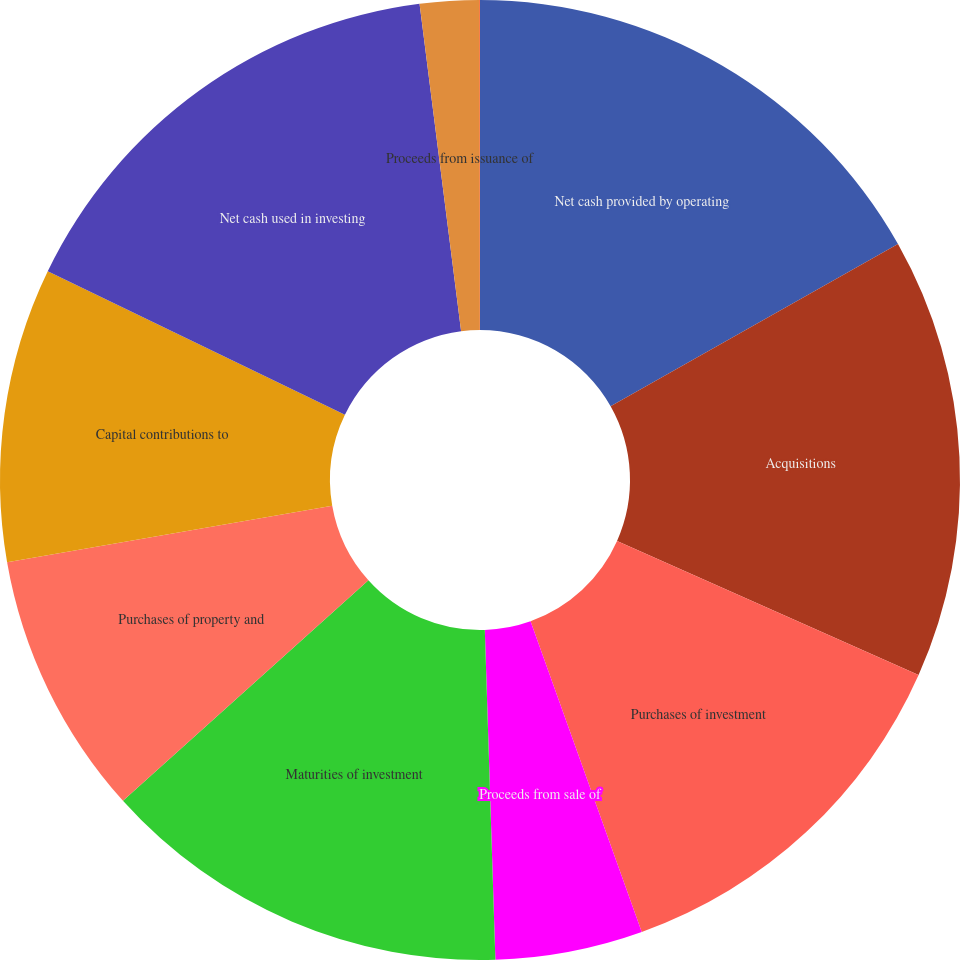Convert chart to OTSL. <chart><loc_0><loc_0><loc_500><loc_500><pie_chart><fcel>Net cash provided by operating<fcel>Acquisitions<fcel>Purchases of investment<fcel>Proceeds from sale of<fcel>Maturities of investment<fcel>Purchases of property and<fcel>Capital contributions to<fcel>Net cash used in investing<fcel>Proceeds from issuance of<fcel>Change in book overdraft<nl><fcel>16.82%<fcel>14.84%<fcel>12.87%<fcel>4.96%<fcel>13.86%<fcel>8.91%<fcel>9.9%<fcel>15.83%<fcel>1.99%<fcel>0.02%<nl></chart> 